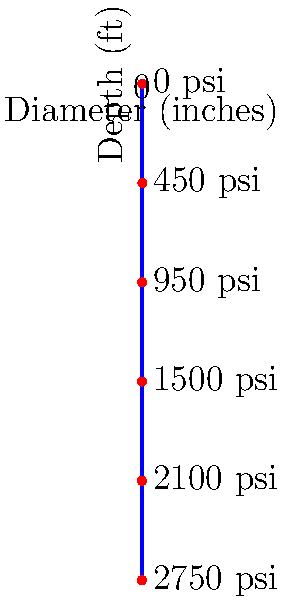Given the wellbore profile shown in the diagram, which illustrates the relationship between well depth, casing diameter, and pressure at various points, calculate the average pressure gradient (in psi/ft) for the section between 3000 ft and 5000 ft. Assume a linear pressure increase within this interval. To solve this problem, we need to follow these steps:

1. Identify the pressures at 3000 ft and 5000 ft:
   At 3000 ft: $P_1 = 1500$ psi
   At 5000 ft: $P_2 = 2750$ psi

2. Calculate the pressure difference:
   $\Delta P = P_2 - P_1 = 2750 - 1500 = 1250$ psi

3. Calculate the depth difference:
   $\Delta D = 5000 - 3000 = 2000$ ft

4. Calculate the average pressure gradient using the formula:
   $\text{Pressure Gradient} = \frac{\Delta P}{\Delta D}$

5. Substitute the values:
   $\text{Pressure Gradient} = \frac{1250 \text{ psi}}{2000 \text{ ft}} = 0.625 \text{ psi/ft}$

Therefore, the average pressure gradient for the section between 3000 ft and 5000 ft is 0.625 psi/ft.
Answer: 0.625 psi/ft 